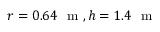<formula> <loc_0><loc_0><loc_500><loc_500>r = 0 . 6 4 m , h = 1 . 4 m</formula> 